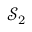Convert formula to latex. <formula><loc_0><loc_0><loc_500><loc_500>\mathcal { S } _ { 2 }</formula> 